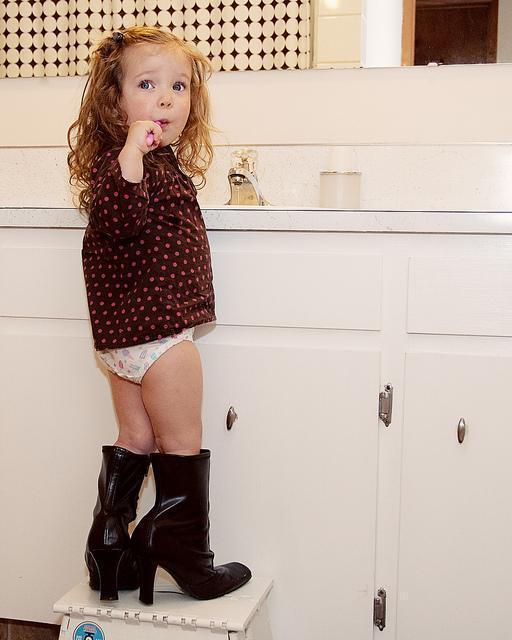Which piece of attire is abnormal for the child to wear?
Indicate the correct response by choosing from the four available options to answer the question.
Options: Boots, nothing, underwear, shirt. Boots. 